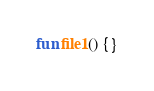<code> <loc_0><loc_0><loc_500><loc_500><_Kotlin_>
fun file1() {}
</code> 